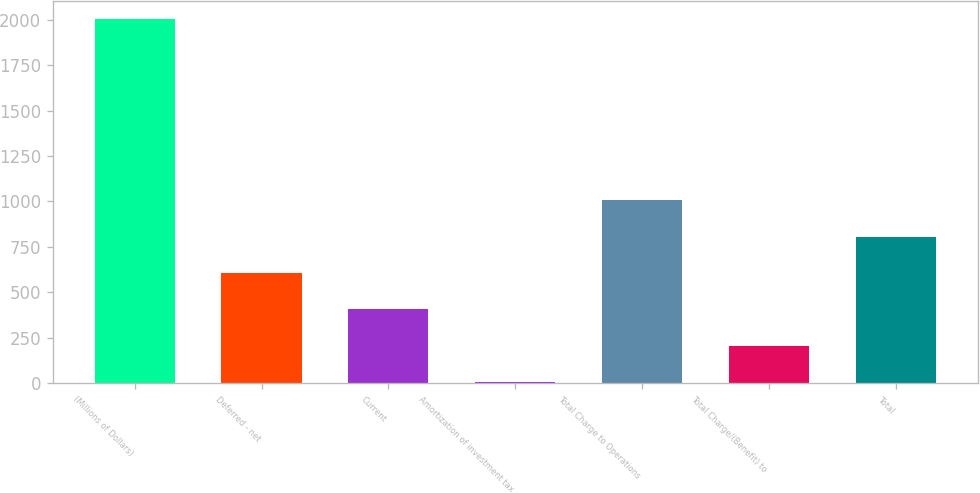Convert chart. <chart><loc_0><loc_0><loc_500><loc_500><bar_chart><fcel>(Millions of Dollars)<fcel>Deferred - net<fcel>Current<fcel>Amortization of investment tax<fcel>Total Charge to Operations<fcel>Total Charge/(Benefit) to<fcel>Total<nl><fcel>2006<fcel>606<fcel>406<fcel>6<fcel>1006<fcel>206<fcel>806<nl></chart> 